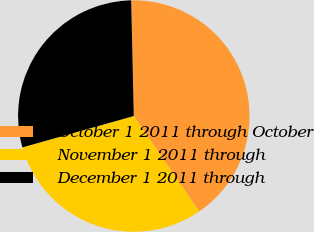Convert chart. <chart><loc_0><loc_0><loc_500><loc_500><pie_chart><fcel>October 1 2011 through October<fcel>November 1 2011 through<fcel>December 1 2011 through<nl><fcel>40.8%<fcel>30.19%<fcel>29.01%<nl></chart> 